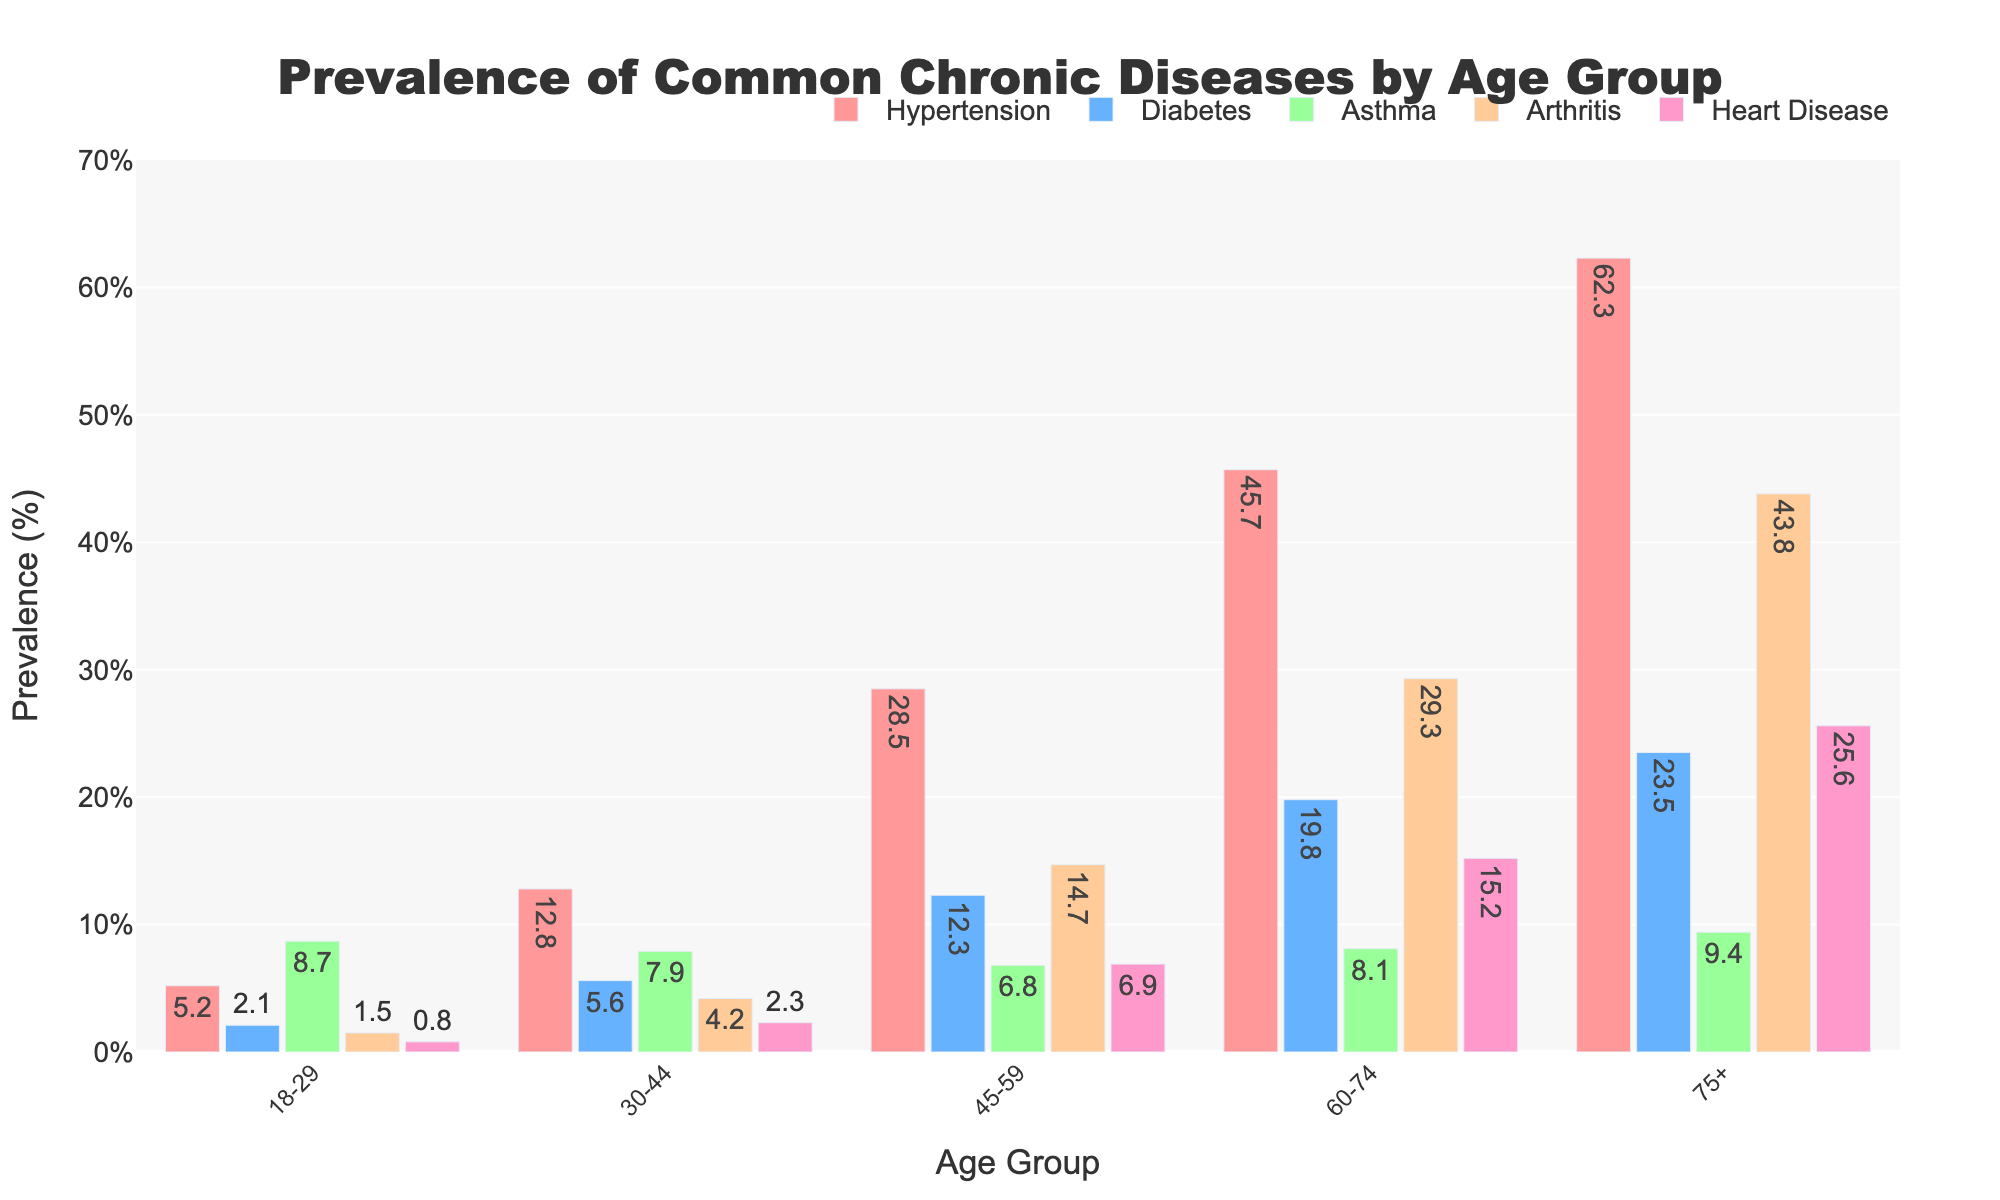What's the age group with the highest prevalence of Arthritis? Looking at the bars for Arthritis, the highest bar corresponds to the 75+ age group.
Answer: 75+ Which disease has the lowest prevalence in the 18-29 age group? By comparing the heights of the bars for different diseases in the 18-29 age group, the shortest bar is for Heart Disease.
Answer: Heart Disease What is the difference in the prevalence of Hypertension between the 60-74 and 75+ age groups? The prevalence of Hypertension in the 60-74 age group is 45.7%, and in the 75+ age group, it is 62.3%. The difference is 62.3% - 45.7%.
Answer: 16.6% Which age group shows an increasing prevalence of Diabetes as the age increases from 18-29 to 75+? To identify this trend, we observe the bar heights for Diabetes across all age groups, which steadily increase from 2.1% to 23.5%.
Answer: All age groups Among the 30-44 age group, which common chronic disease has the highest prevalence? We need to check the bar heights in the 30-44 age group; Hypertension has the tallest bar with 12.8%.
Answer: Hypertension Compare the prevalence of Asthma between the 18-29 and 60-74 age groups. Which age group has a higher prevalence? By comparing bar heights, the prevalence of Asthma in the 18-29 age group is 8.7% and in the 60-74 age group, it is 8.1%. The 18-29 age group has a higher prevalence.
Answer: 18-29 What is the average prevalence of Heart Disease across all age groups? Sum the prevalence values for Heart Disease (0.8, 2.3, 6.9, 15.2, 25.6) which equals 50.8%. Divide by the number of age groups (5).
Answer: 10.16% What is the prevalence of Hypertension in the 45-59 age group compared to Diabetes in the 75+ age group? The prevalence of Hypertension in the 45-59 age group is 28.5%, and the prevalence of Diabetes in the 75+ age group is 23.5%. The prevalence of Hypertension in the 45-59 age group is higher.
Answer: Hypertension in 45-59 